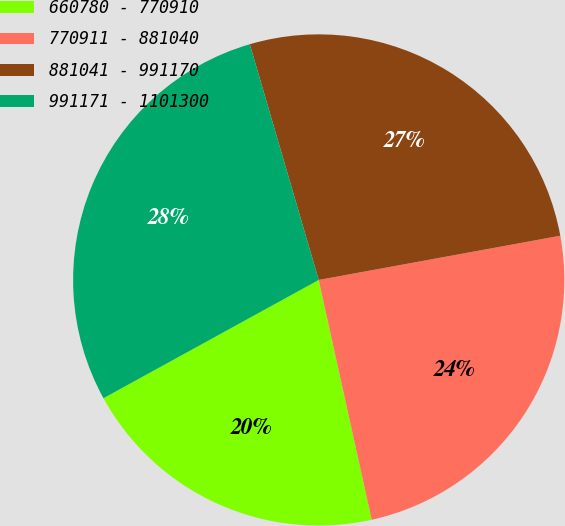Convert chart to OTSL. <chart><loc_0><loc_0><loc_500><loc_500><pie_chart><fcel>660780 - 770910<fcel>770911 - 881040<fcel>881041 - 991170<fcel>991171 - 1101300<nl><fcel>20.47%<fcel>24.42%<fcel>26.65%<fcel>28.47%<nl></chart> 